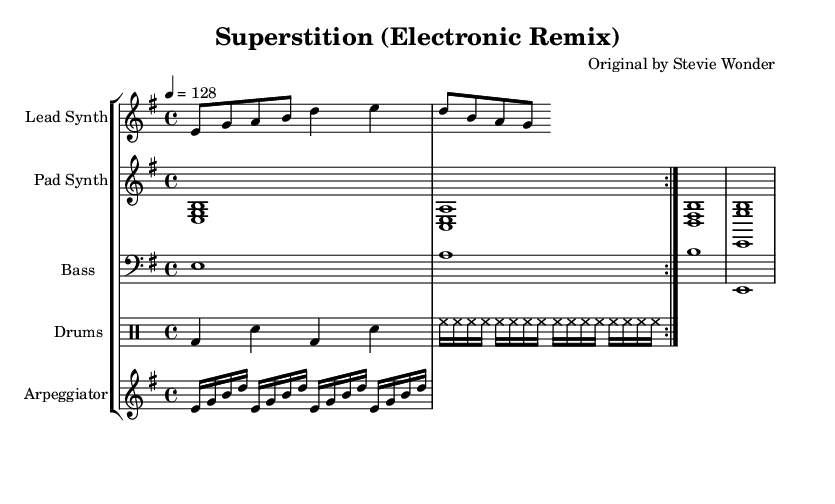What is the key signature of this music? The key signature indicated is E minor, which has one sharp (F#). This information can be derived from the key signature shown at the beginning of the score.
Answer: E minor What is the time signature of this piece? The time signature present in the music sheet is 4/4, meaning there are four beats in each measure, with each quarter note getting one beat. This is indicated at the beginning of the score.
Answer: 4/4 What is the tempo marking for this piece? The tempo marking provided in the sheet music is 128 beats per minute, indicated by the tempo notation at the start of the staff for the Lead Synth.
Answer: 128 How many different instruments are represented in this score? There are four distinct instrument staves in the score: Lead Synth, Pad Synth, Bass, and Drums. By counting the labeled staves, I find this total.
Answer: Four What is the rhythmic pattern of the drums in the first measure? In the first measure, the drum pattern consists of a bass drum (bd) on beats one and three and a snare (sn) on beats two and four. The hi-hat (hh) plays continuously on every eighth note. This rhythmic pattern can be analyzed by looking at the drum staff notation.
Answer: Bass, Snare, Hi-hat What type of synthesizer sound is represented in the Pad Synth staff? The Pad Synth staff consists of sustained chord notes (e, g, b) indicating a pad sound, which is typical in electronic music for creating atmospheric textures. This can be identified from the chords laid out in the Pad Synth part.
Answer: Pad sound How is the Arpeggiator part structured in terms of note repetitions? The Arpeggiator part consists of four repetitions of the notes E, G, B, and D, played in sequence every sixteenth note. This can be seen by looking for the repeat indication along with the specific notes listed under the Arpeggiator staff.
Answer: Four repetitions 